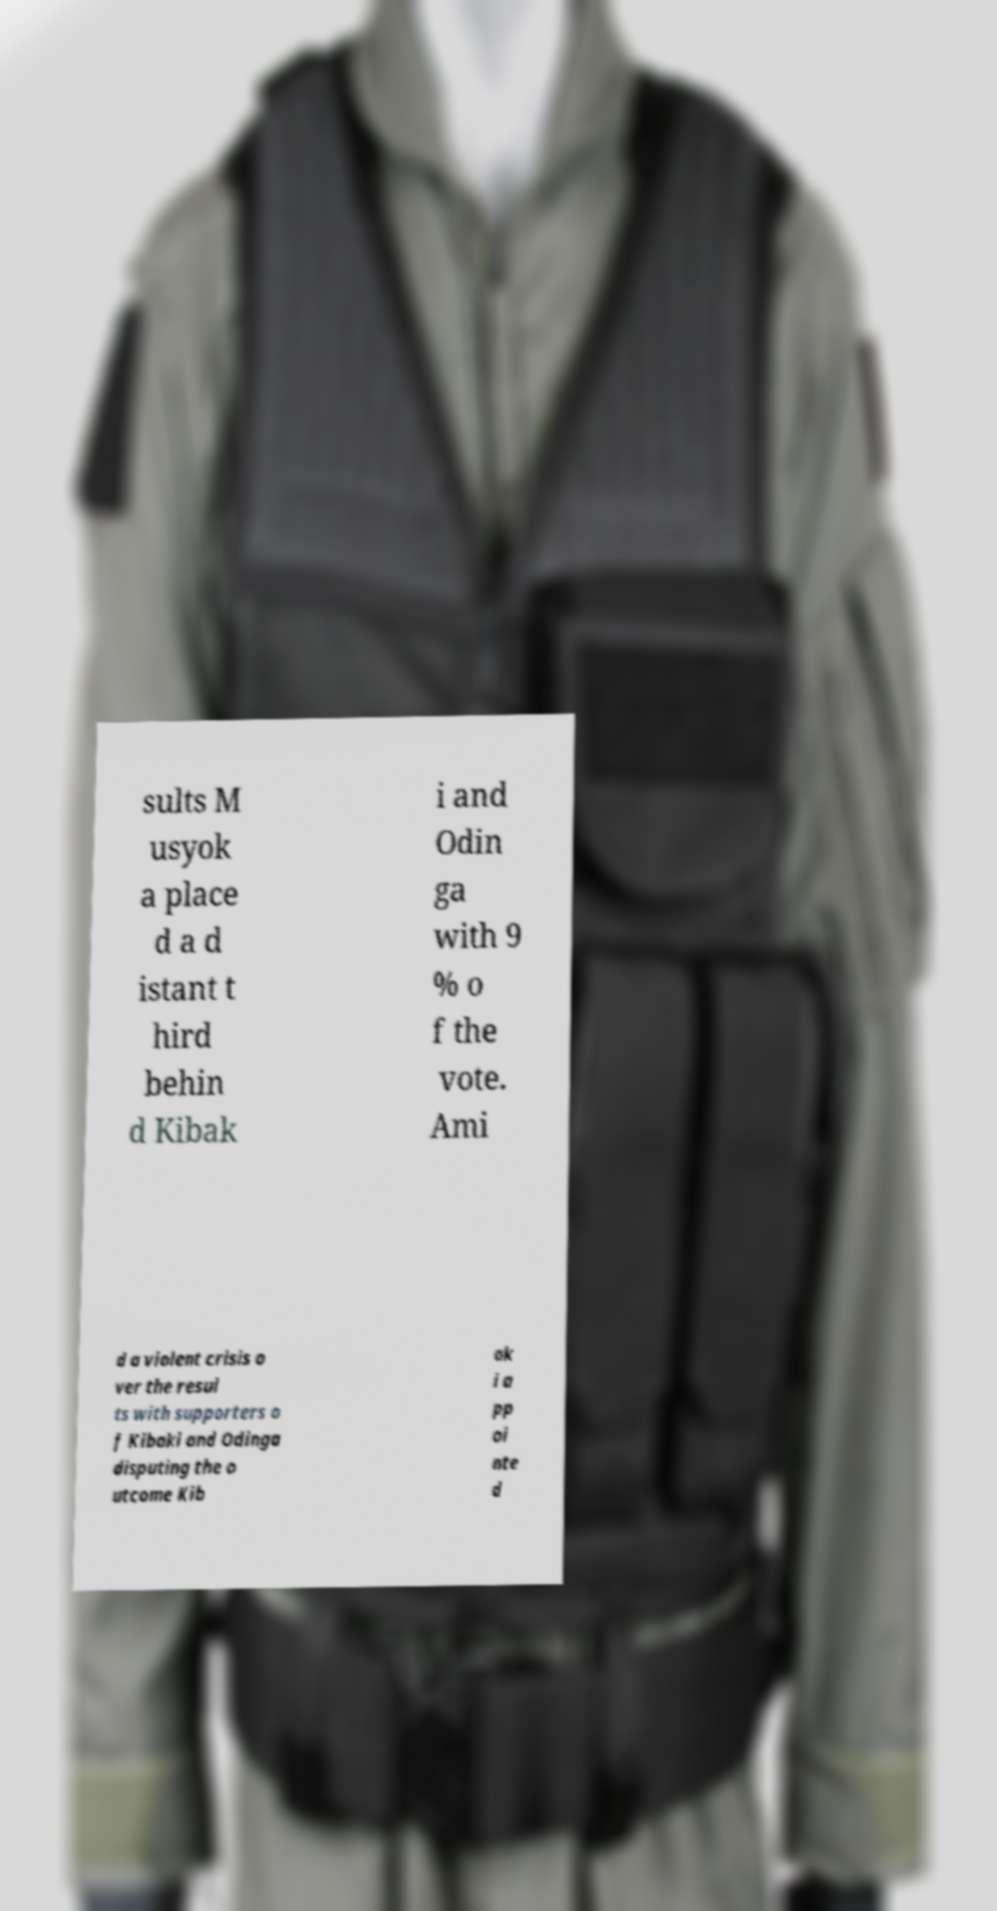Could you extract and type out the text from this image? sults M usyok a place d a d istant t hird behin d Kibak i and Odin ga with 9 % o f the vote. Ami d a violent crisis o ver the resul ts with supporters o f Kibaki and Odinga disputing the o utcome Kib ak i a pp oi nte d 